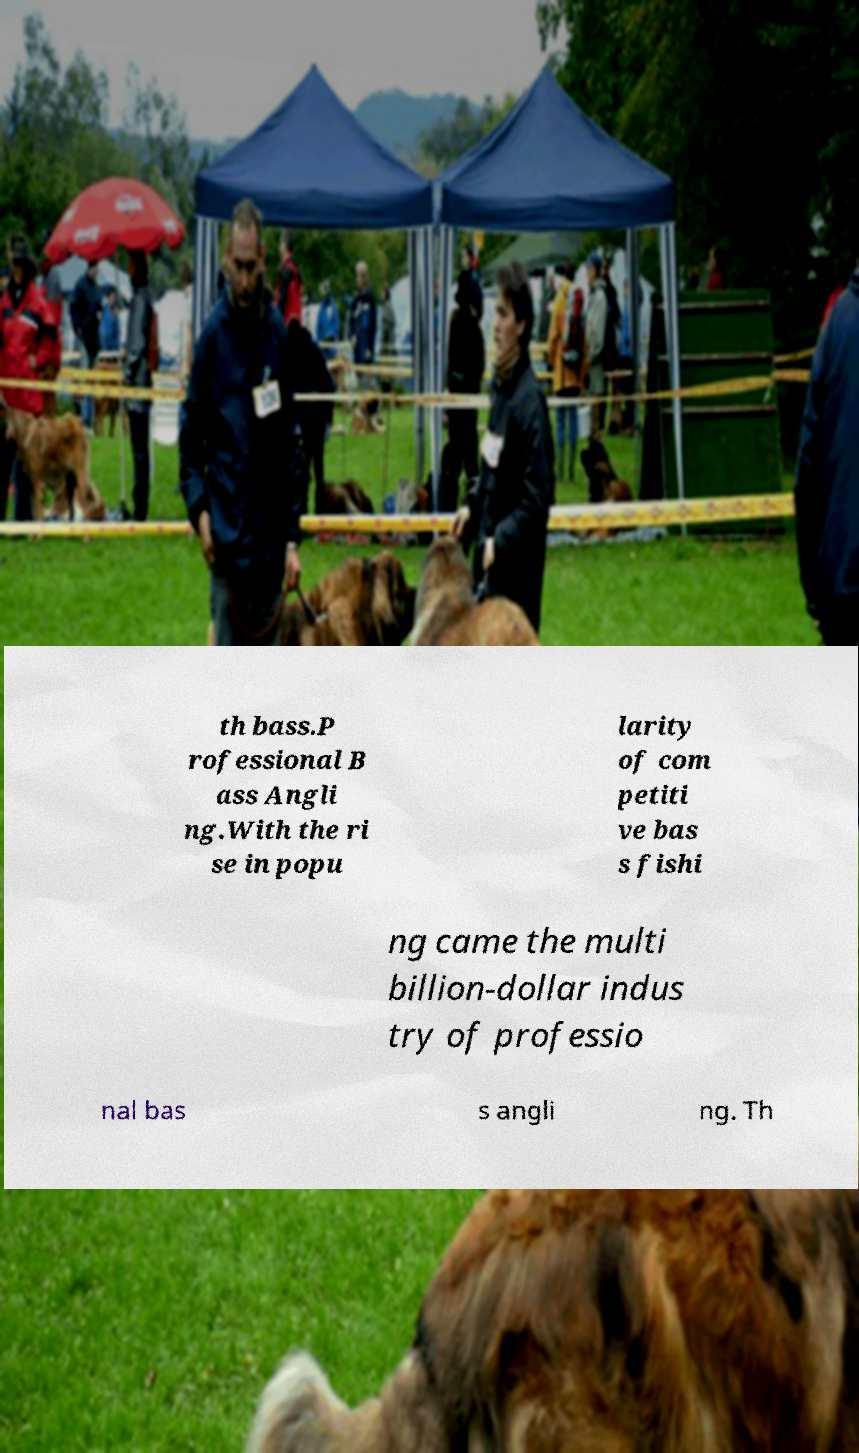There's text embedded in this image that I need extracted. Can you transcribe it verbatim? th bass.P rofessional B ass Angli ng.With the ri se in popu larity of com petiti ve bas s fishi ng came the multi billion-dollar indus try of professio nal bas s angli ng. Th 